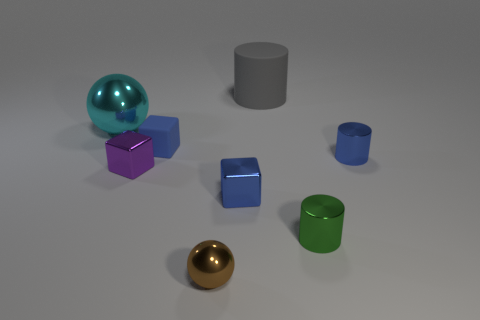How big is the cyan object?
Offer a terse response. Large. How many purple objects are either tiny metallic spheres or tiny shiny things?
Keep it short and to the point. 1. What number of other tiny matte things have the same shape as the gray thing?
Offer a very short reply. 0. How many matte things have the same size as the gray cylinder?
Provide a succinct answer. 0. There is a tiny blue thing that is the same shape as the gray thing; what material is it?
Make the answer very short. Metal. There is a large thing that is on the right side of the large cyan metallic sphere; what is its color?
Offer a terse response. Gray. Is the number of blue matte cubes in front of the purple metallic block greater than the number of tiny blue metallic things?
Ensure brevity in your answer.  No. What is the color of the matte cylinder?
Offer a very short reply. Gray. What is the shape of the large thing that is to the left of the big thing right of the rubber object that is in front of the cyan ball?
Make the answer very short. Sphere. The object that is in front of the small purple shiny object and to the right of the gray cylinder is made of what material?
Keep it short and to the point. Metal. 